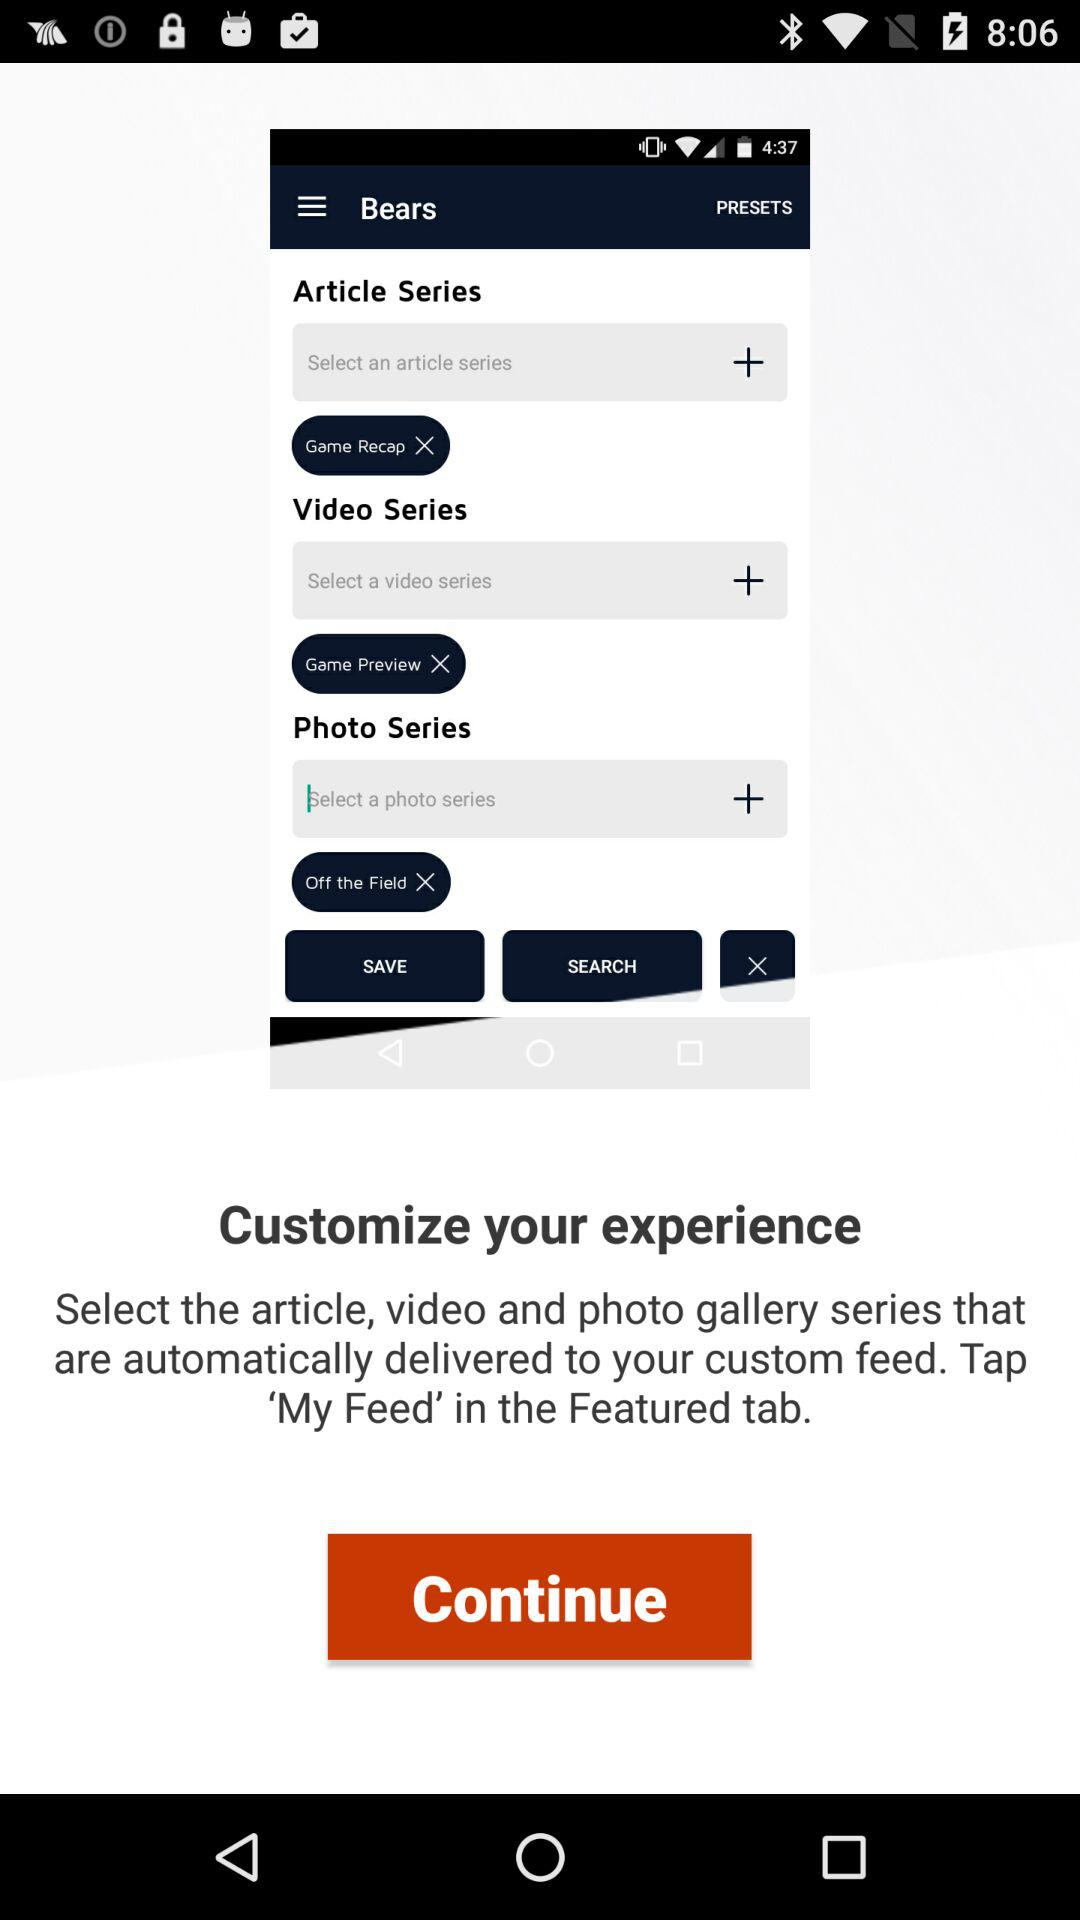Where can we tap in the Featured tab to select the article, video and photo gallery series? You can tap on 'My Feed' in the Featured tab. 